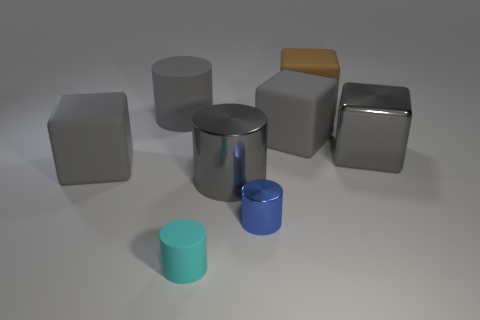There is a cyan thing in front of the large gray rubber cube to the left of the tiny cyan cylinder; what is its shape?
Make the answer very short. Cylinder. Are there any other things that have the same color as the large metal cylinder?
Give a very brief answer. Yes. Is the size of the blue object the same as the gray shiny thing to the left of the large brown object?
Ensure brevity in your answer.  No. How many tiny things are either blue shiny cylinders or metallic cylinders?
Give a very brief answer. 1. Is the number of gray metallic objects greater than the number of blue cylinders?
Make the answer very short. Yes. There is a large matte block left of the small cylinder that is on the right side of the cyan cylinder; what number of large cubes are on the right side of it?
Offer a very short reply. 3. The big brown matte thing is what shape?
Offer a terse response. Cube. How many other objects are there of the same material as the brown block?
Provide a succinct answer. 4. Do the blue object and the gray metallic block have the same size?
Make the answer very short. No. There is a gray thing on the right side of the brown matte cube; what shape is it?
Your response must be concise. Cube. 